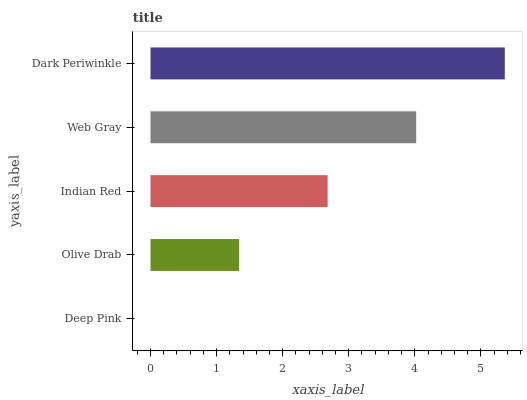Is Deep Pink the minimum?
Answer yes or no. Yes. Is Dark Periwinkle the maximum?
Answer yes or no. Yes. Is Olive Drab the minimum?
Answer yes or no. No. Is Olive Drab the maximum?
Answer yes or no. No. Is Olive Drab greater than Deep Pink?
Answer yes or no. Yes. Is Deep Pink less than Olive Drab?
Answer yes or no. Yes. Is Deep Pink greater than Olive Drab?
Answer yes or no. No. Is Olive Drab less than Deep Pink?
Answer yes or no. No. Is Indian Red the high median?
Answer yes or no. Yes. Is Indian Red the low median?
Answer yes or no. Yes. Is Deep Pink the high median?
Answer yes or no. No. Is Deep Pink the low median?
Answer yes or no. No. 